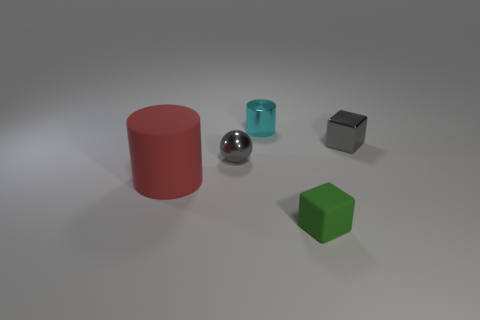Subtract 1 cylinders. How many cylinders are left? 1 Add 3 large cylinders. How many objects exist? 8 Subtract 0 purple cubes. How many objects are left? 5 Subtract all balls. How many objects are left? 4 Subtract all gray cubes. Subtract all purple balls. How many cubes are left? 1 Subtract all purple spheres. How many red blocks are left? 0 Subtract all small purple matte balls. Subtract all cyan cylinders. How many objects are left? 4 Add 5 cylinders. How many cylinders are left? 7 Add 1 small yellow matte cylinders. How many small yellow matte cylinders exist? 1 